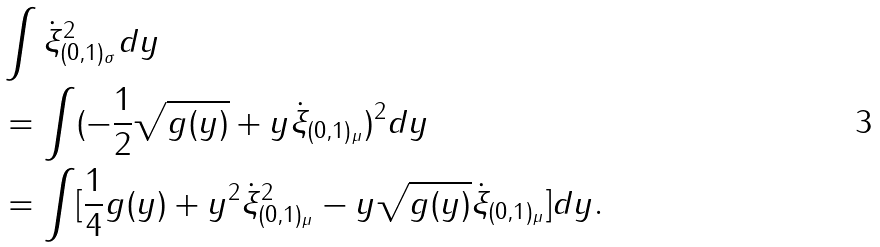Convert formula to latex. <formula><loc_0><loc_0><loc_500><loc_500>& \int \dot { \xi } ^ { 2 } _ { ( 0 , 1 ) _ { \sigma } } d y \\ & = \int ( - \frac { 1 } { 2 } \sqrt { g ( y ) } + y \dot { \xi } _ { ( 0 , 1 ) _ { \mu } } ) ^ { 2 } d y \\ & = \int [ \frac { 1 } { 4 } g ( y ) + y ^ { 2 } \dot { \xi } ^ { 2 } _ { ( 0 , 1 ) _ { \mu } } - y \sqrt { g ( y ) } \dot { \xi } _ { ( 0 , 1 ) _ { \mu } } ] d y .</formula> 